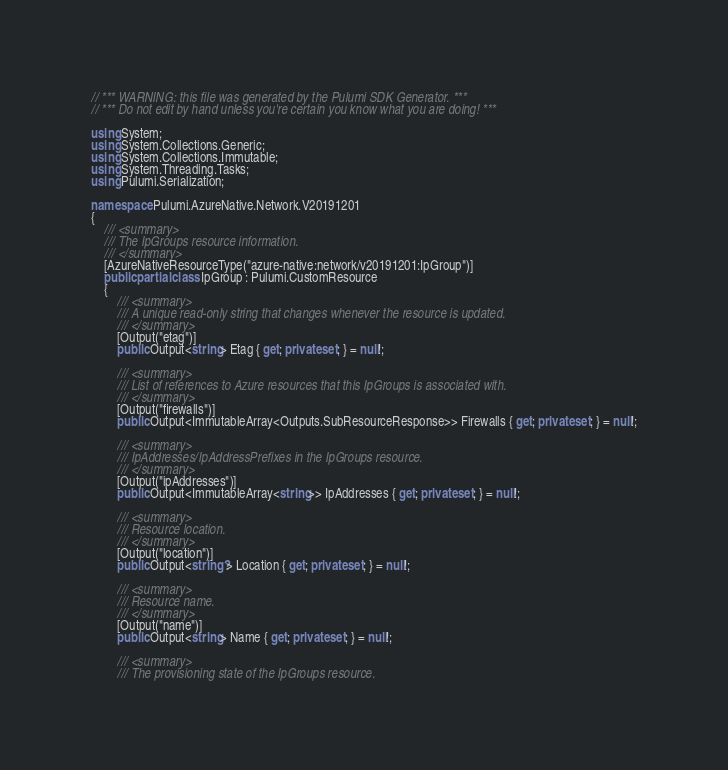Convert code to text. <code><loc_0><loc_0><loc_500><loc_500><_C#_>// *** WARNING: this file was generated by the Pulumi SDK Generator. ***
// *** Do not edit by hand unless you're certain you know what you are doing! ***

using System;
using System.Collections.Generic;
using System.Collections.Immutable;
using System.Threading.Tasks;
using Pulumi.Serialization;

namespace Pulumi.AzureNative.Network.V20191201
{
    /// <summary>
    /// The IpGroups resource information.
    /// </summary>
    [AzureNativeResourceType("azure-native:network/v20191201:IpGroup")]
    public partial class IpGroup : Pulumi.CustomResource
    {
        /// <summary>
        /// A unique read-only string that changes whenever the resource is updated.
        /// </summary>
        [Output("etag")]
        public Output<string> Etag { get; private set; } = null!;

        /// <summary>
        /// List of references to Azure resources that this IpGroups is associated with.
        /// </summary>
        [Output("firewalls")]
        public Output<ImmutableArray<Outputs.SubResourceResponse>> Firewalls { get; private set; } = null!;

        /// <summary>
        /// IpAddresses/IpAddressPrefixes in the IpGroups resource.
        /// </summary>
        [Output("ipAddresses")]
        public Output<ImmutableArray<string>> IpAddresses { get; private set; } = null!;

        /// <summary>
        /// Resource location.
        /// </summary>
        [Output("location")]
        public Output<string?> Location { get; private set; } = null!;

        /// <summary>
        /// Resource name.
        /// </summary>
        [Output("name")]
        public Output<string> Name { get; private set; } = null!;

        /// <summary>
        /// The provisioning state of the IpGroups resource.</code> 